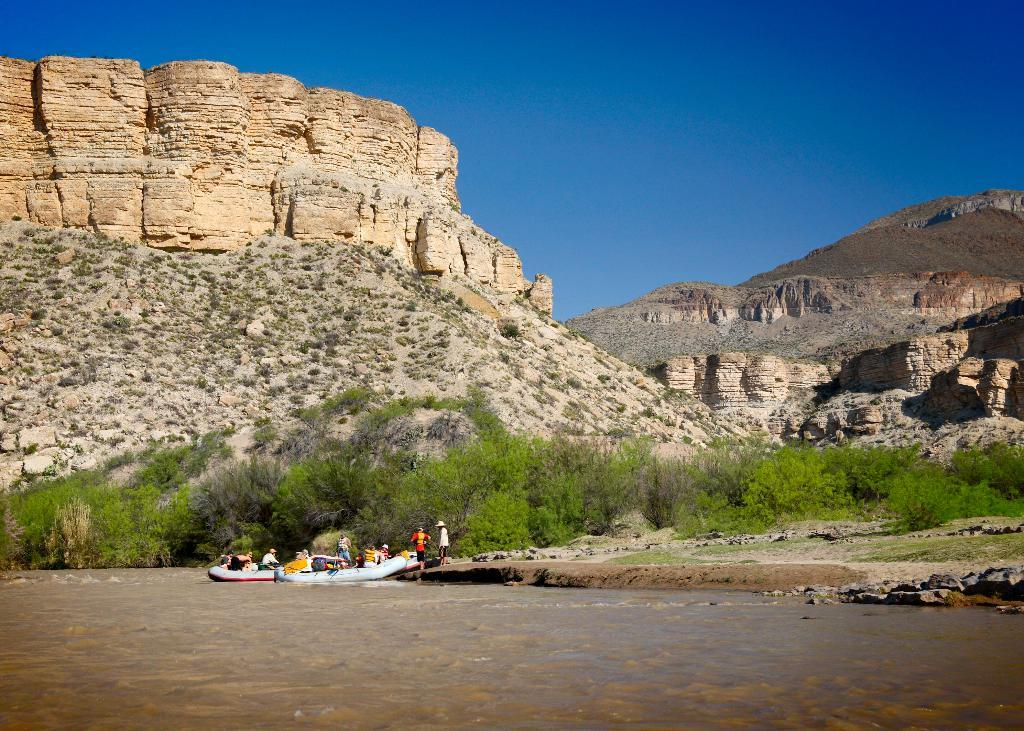What type of natural formation is visible in the image? There is a mountain in the image. What type of vegetation can be seen in the image? There are trees in the image. What are the people in the image doing? The people in the image are in boats. What is the condition of the sky in the image? The sky is clear in the image. What type of seed can be seen growing on the mountain in the image? There is no seed visible on the mountain in the image. What direction is the sun facing in the image? The provided facts do not mention the sun or its direction in the image. 